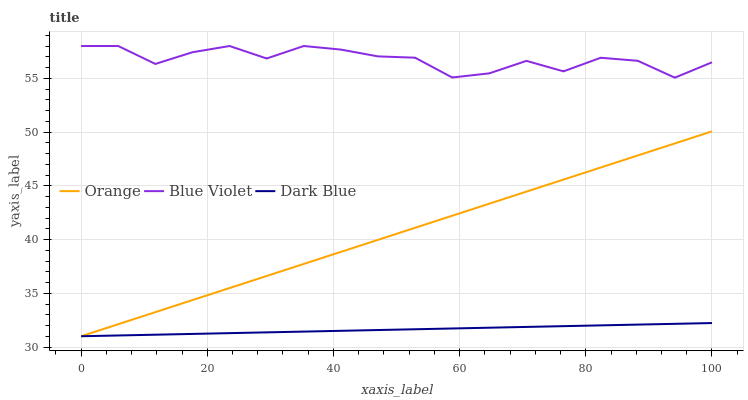Does Blue Violet have the minimum area under the curve?
Answer yes or no. No. Does Dark Blue have the maximum area under the curve?
Answer yes or no. No. Is Dark Blue the smoothest?
Answer yes or no. No. Is Dark Blue the roughest?
Answer yes or no. No. Does Blue Violet have the lowest value?
Answer yes or no. No. Does Dark Blue have the highest value?
Answer yes or no. No. Is Dark Blue less than Blue Violet?
Answer yes or no. Yes. Is Blue Violet greater than Orange?
Answer yes or no. Yes. Does Dark Blue intersect Blue Violet?
Answer yes or no. No. 